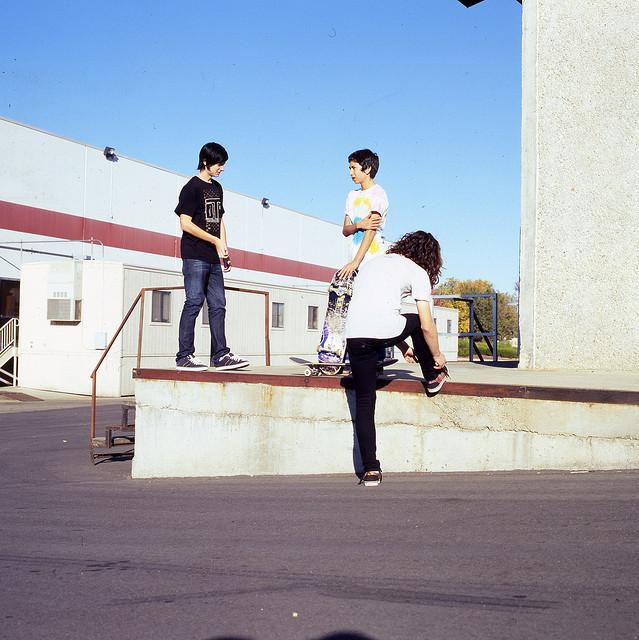Why is the long haired boy touching his shoe? tying laces 